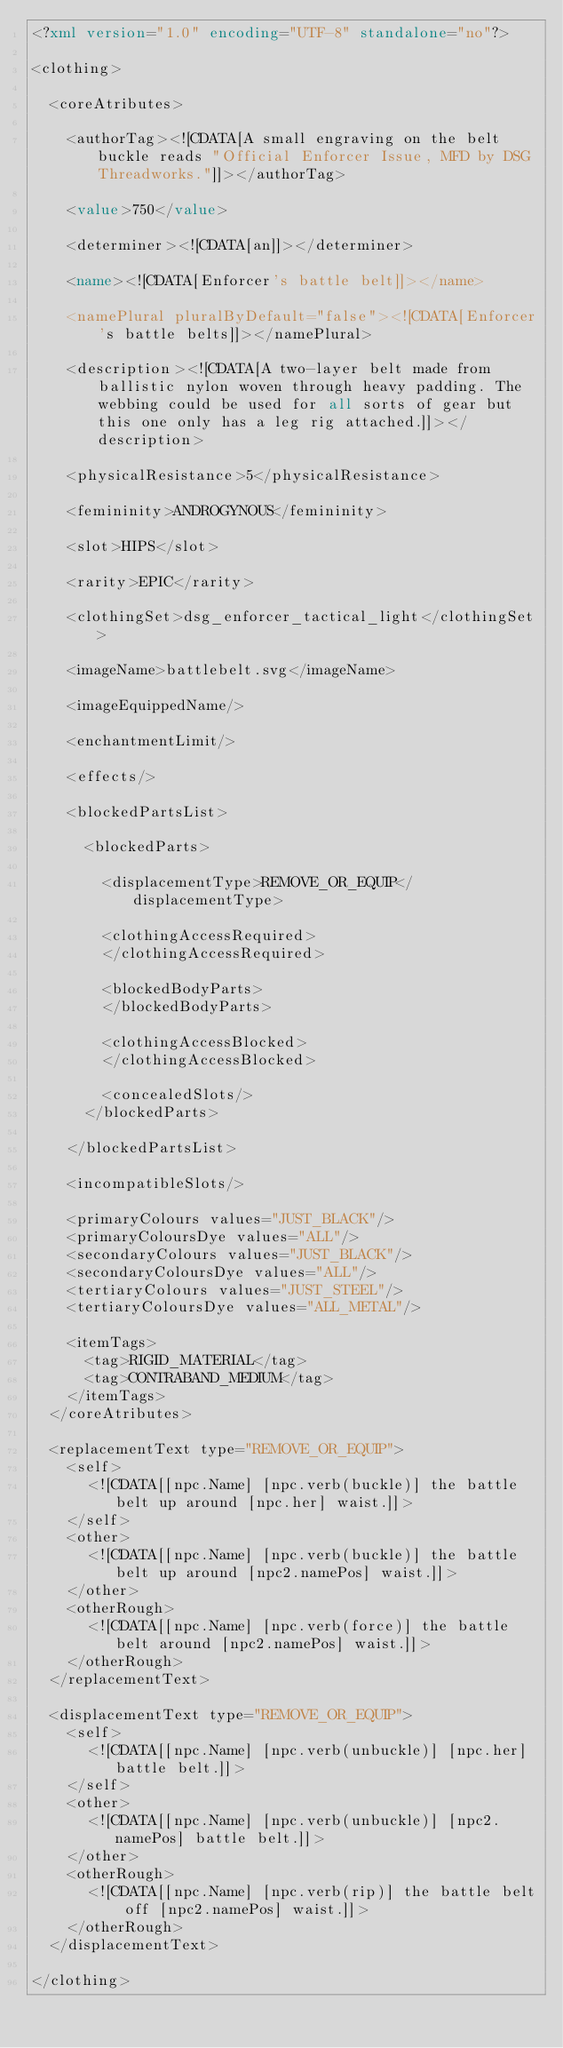Convert code to text. <code><loc_0><loc_0><loc_500><loc_500><_XML_><?xml version="1.0" encoding="UTF-8" standalone="no"?>

<clothing>

	<coreAtributes>
	
		<authorTag><![CDATA[A small engraving on the belt buckle reads "Official Enforcer Issue, MFD by DSG Threadworks."]]></authorTag>

		<value>750</value> 

		<determiner><![CDATA[an]]></determiner>

		<name><![CDATA[Enforcer's battle belt]]></name>

		<namePlural pluralByDefault="false"><![CDATA[Enforcer's battle belts]]></namePlural> 

		<description><![CDATA[A two-layer belt made from ballistic nylon woven through heavy padding. The webbing could be used for all sorts of gear but this one only has a leg rig attached.]]></description> 

		<physicalResistance>5</physicalResistance> 

		<femininity>ANDROGYNOUS</femininity> 

		<slot>HIPS</slot> 

		<rarity>EPIC</rarity> 

		<clothingSet>dsg_enforcer_tactical_light</clothingSet> 

		<imageName>battlebelt.svg</imageName> 

		<imageEquippedName/> 

		<enchantmentLimit/>

		<effects/> 

		<blockedPartsList> 

			<blockedParts>

				<displacementType>REMOVE_OR_EQUIP</displacementType> 

				<clothingAccessRequired>
				</clothingAccessRequired>

				<blockedBodyParts> 
				</blockedBodyParts>

				<clothingAccessBlocked> 
				</clothingAccessBlocked>

				<concealedSlots/> 
			</blockedParts>

		</blockedPartsList>

		<incompatibleSlots/> 

		<primaryColours values="JUST_BLACK"/> 
		<primaryColoursDye values="ALL"/>
		<secondaryColours values="JUST_BLACK"/> 
		<secondaryColoursDye values="ALL"/>
		<tertiaryColours values="JUST_STEEL"/> 
		<tertiaryColoursDye values="ALL_METAL"/>

		<itemTags> 
			<tag>RIGID_MATERIAL</tag>
			<tag>CONTRABAND_MEDIUM</tag>
		</itemTags>
	</coreAtributes>

	<replacementText type="REMOVE_OR_EQUIP">
		<self>
			<![CDATA[[npc.Name] [npc.verb(buckle)] the battle belt up around [npc.her] waist.]]>
		</self>
		<other>
			<![CDATA[[npc.Name] [npc.verb(buckle)] the battle belt up around [npc2.namePos] waist.]]>
		</other>
		<otherRough>
			<![CDATA[[npc.Name] [npc.verb(force)] the battle belt around [npc2.namePos] waist.]]>
		</otherRough>
	</replacementText>

	<displacementText type="REMOVE_OR_EQUIP">
		<self>
		  <![CDATA[[npc.Name] [npc.verb(unbuckle)] [npc.her] battle belt.]]>
		</self>
		<other>
		  <![CDATA[[npc.Name] [npc.verb(unbuckle)] [npc2.namePos] battle belt.]]>
		</other>
		<otherRough>
		  <![CDATA[[npc.Name] [npc.verb(rip)] the battle belt off [npc2.namePos] waist.]]>
		</otherRough>
	</displacementText>
	
</clothing>
</code> 